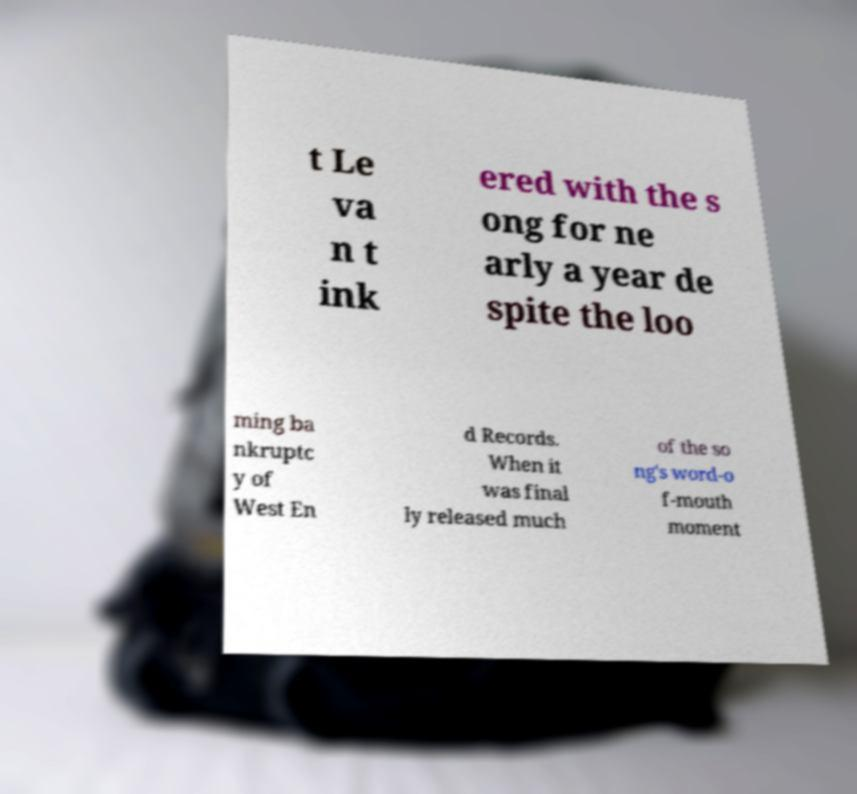Please identify and transcribe the text found in this image. t Le va n t ink ered with the s ong for ne arly a year de spite the loo ming ba nkruptc y of West En d Records. When it was final ly released much of the so ng's word-o f-mouth moment 